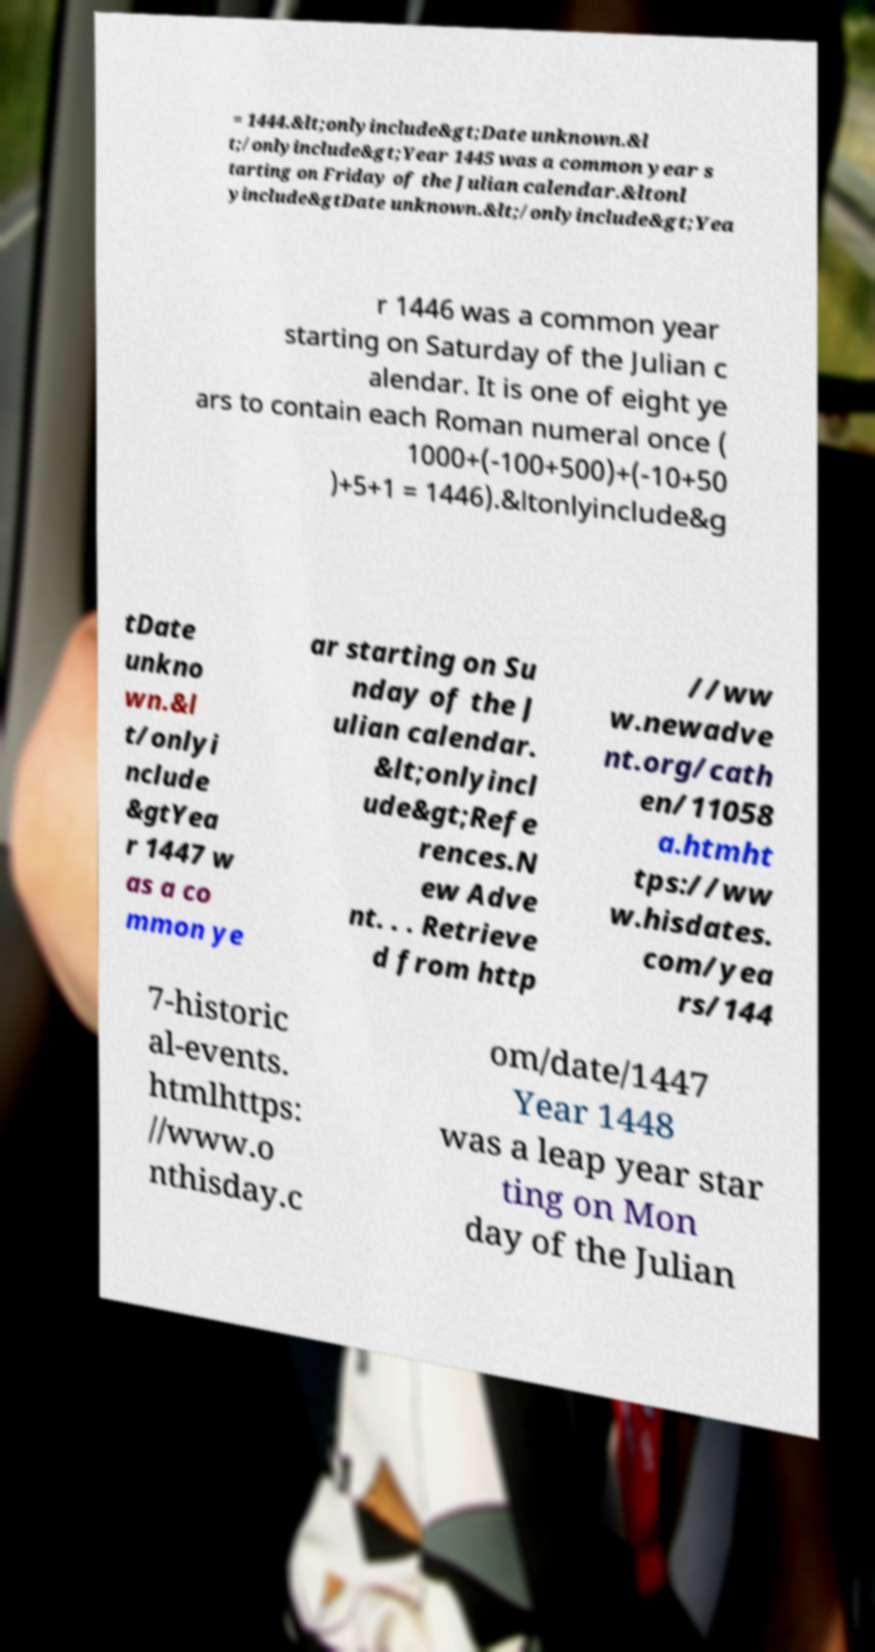Please identify and transcribe the text found in this image. = 1444.&lt;onlyinclude&gt;Date unknown.&l t;/onlyinclude&gt;Year 1445 was a common year s tarting on Friday of the Julian calendar.&ltonl yinclude&gtDate unknown.&lt;/onlyinclude&gt;Yea r 1446 was a common year starting on Saturday of the Julian c alendar. It is one of eight ye ars to contain each Roman numeral once ( 1000+(-100+500)+(-10+50 )+5+1 = 1446).&ltonlyinclude&g tDate unkno wn.&l t/onlyi nclude &gtYea r 1447 w as a co mmon ye ar starting on Su nday of the J ulian calendar. &lt;onlyincl ude&gt;Refe rences.N ew Adve nt. . . Retrieve d from http //ww w.newadve nt.org/cath en/11058 a.htmht tps://ww w.hisdates. com/yea rs/144 7-historic al-events. htmlhttps: //www.o nthisday.c om/date/1447 Year 1448 was a leap year star ting on Mon day of the Julian 